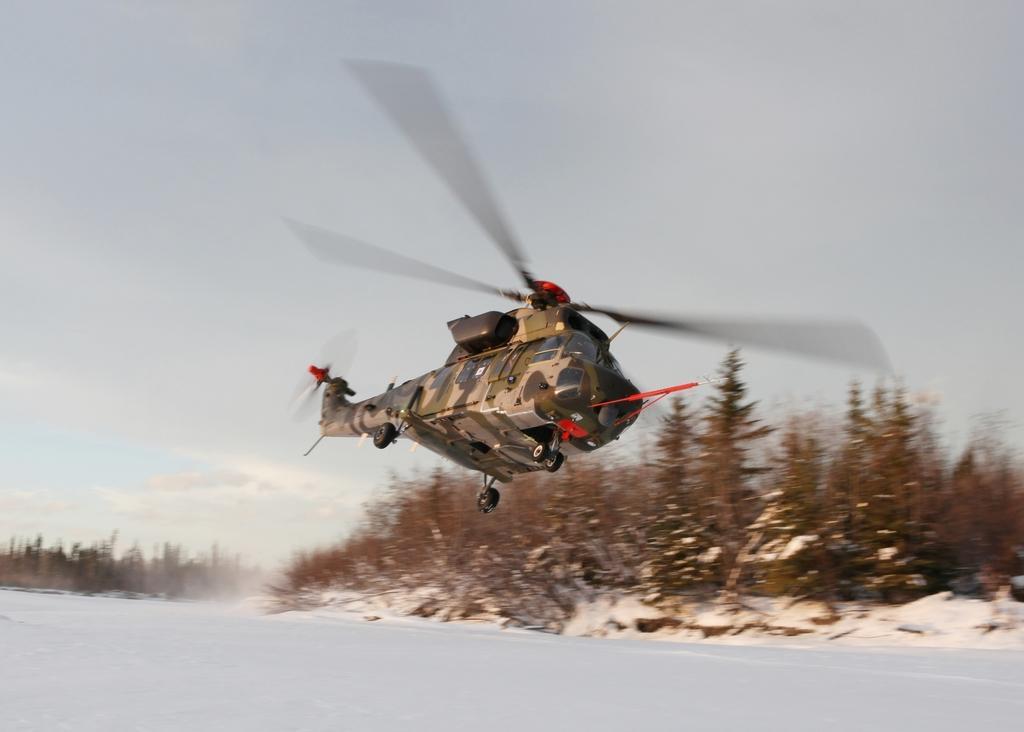How would you summarize this image in a sentence or two? In this picture there is a plane flying in the air and there are trees in the background. 